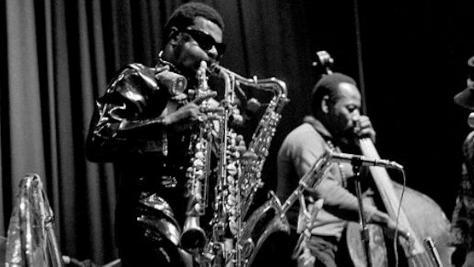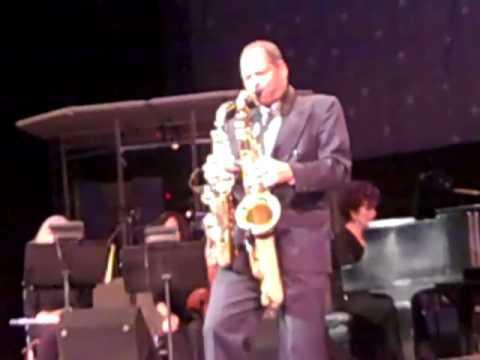The first image is the image on the left, the second image is the image on the right. For the images shown, is this caption "Two men, each playing at least two saxophones simultaneously, are the sole people playing musical instruments in the images." true? Answer yes or no. No. 